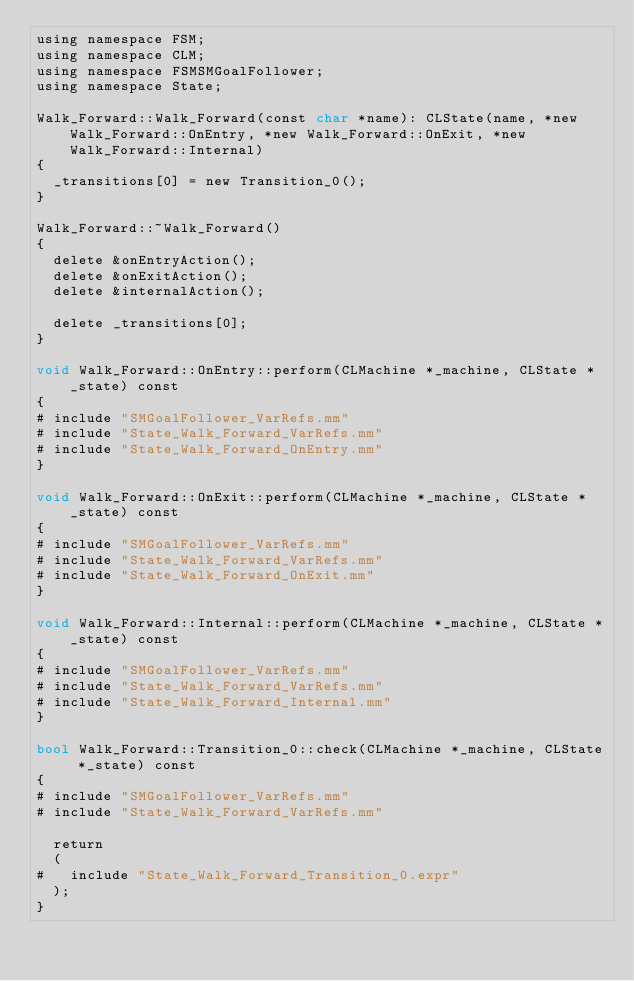<code> <loc_0><loc_0><loc_500><loc_500><_ObjectiveC_>using namespace FSM;
using namespace CLM;
using namespace FSMSMGoalFollower;
using namespace State;

Walk_Forward::Walk_Forward(const char *name): CLState(name, *new Walk_Forward::OnEntry, *new Walk_Forward::OnExit, *new Walk_Forward::Internal)
{
	_transitions[0] = new Transition_0();
}

Walk_Forward::~Walk_Forward()
{
	delete &onEntryAction();
	delete &onExitAction();
	delete &internalAction();

	delete _transitions[0];
}

void Walk_Forward::OnEntry::perform(CLMachine *_machine, CLState *_state) const
{
#	include "SMGoalFollower_VarRefs.mm"
#	include "State_Walk_Forward_VarRefs.mm"
#	include "State_Walk_Forward_OnEntry.mm"
}

void Walk_Forward::OnExit::perform(CLMachine *_machine, CLState *_state) const
{
#	include "SMGoalFollower_VarRefs.mm"
#	include "State_Walk_Forward_VarRefs.mm"
#	include "State_Walk_Forward_OnExit.mm"
}

void Walk_Forward::Internal::perform(CLMachine *_machine, CLState *_state) const
{
#	include "SMGoalFollower_VarRefs.mm"
#	include "State_Walk_Forward_VarRefs.mm"
#	include "State_Walk_Forward_Internal.mm"
}

bool Walk_Forward::Transition_0::check(CLMachine *_machine, CLState *_state) const
{
#	include "SMGoalFollower_VarRefs.mm"
#	include "State_Walk_Forward_VarRefs.mm"

	return
	(
#		include "State_Walk_Forward_Transition_0.expr"
	);
}
</code> 